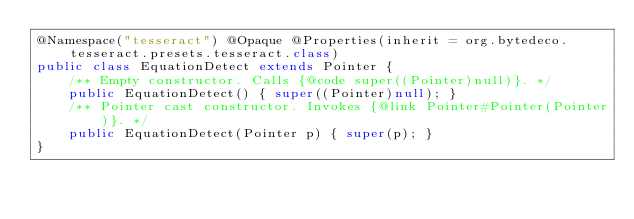<code> <loc_0><loc_0><loc_500><loc_500><_Java_>@Namespace("tesseract") @Opaque @Properties(inherit = org.bytedeco.tesseract.presets.tesseract.class)
public class EquationDetect extends Pointer {
    /** Empty constructor. Calls {@code super((Pointer)null)}. */
    public EquationDetect() { super((Pointer)null); }
    /** Pointer cast constructor. Invokes {@link Pointer#Pointer(Pointer)}. */
    public EquationDetect(Pointer p) { super(p); }
}
</code> 